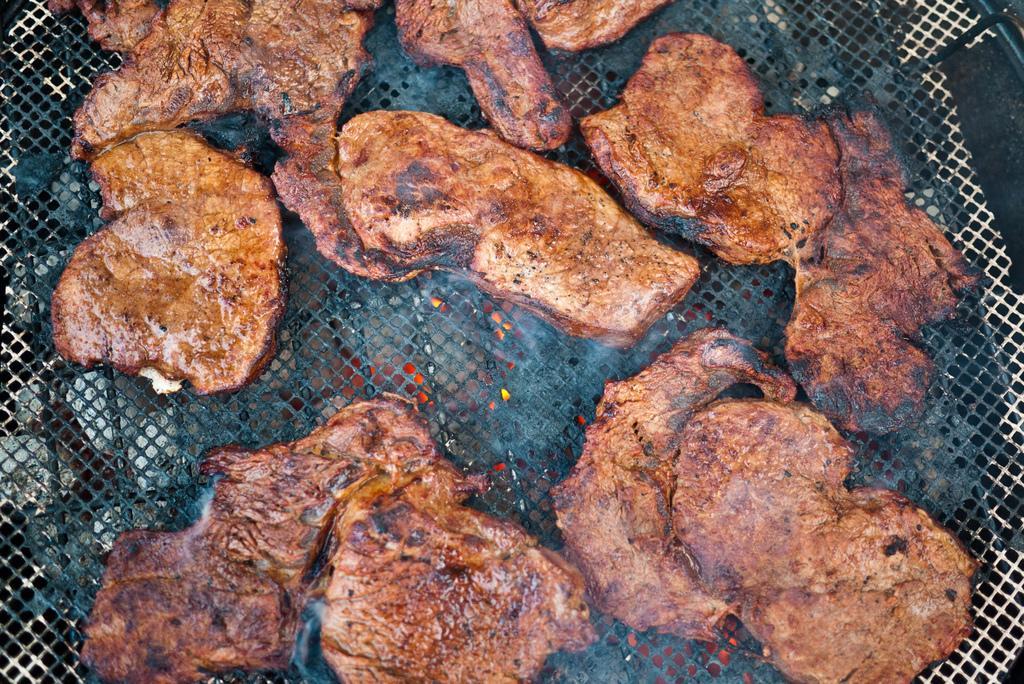Please provide a concise description of this image. In the image there is some meat being grilled on a mesh, under the mesh there is fire. 